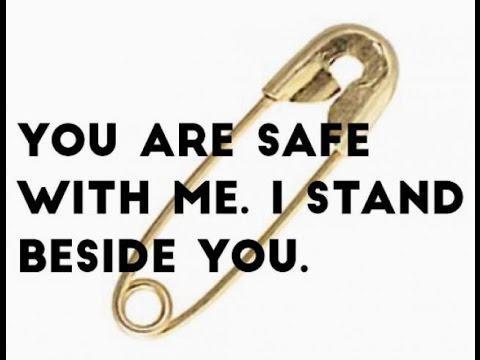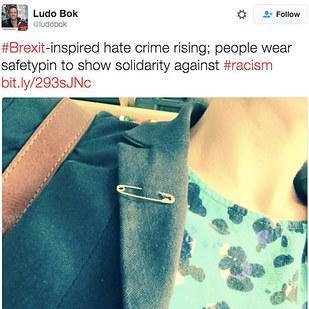The first image is the image on the left, the second image is the image on the right. Given the left and right images, does the statement "There are three people saving the world by wearing safety pins." hold true? Answer yes or no. No. The first image is the image on the left, the second image is the image on the right. Examine the images to the left and right. Is the description "Each image shows a safety pin attached to someone's shirt, though no part of their head is visible." accurate? Answer yes or no. No. 